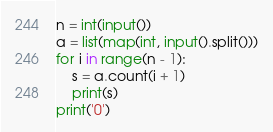<code> <loc_0><loc_0><loc_500><loc_500><_Python_>n = int(input())
a = list(map(int, input().split()))
for i in range(n - 1):
    s = a.count(i + 1)
    print(s)
print('0')</code> 